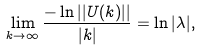Convert formula to latex. <formula><loc_0><loc_0><loc_500><loc_500>\lim _ { k \to \infty } \frac { - \ln | | U ( k ) | | } { | k | } = \ln | \lambda | ,</formula> 